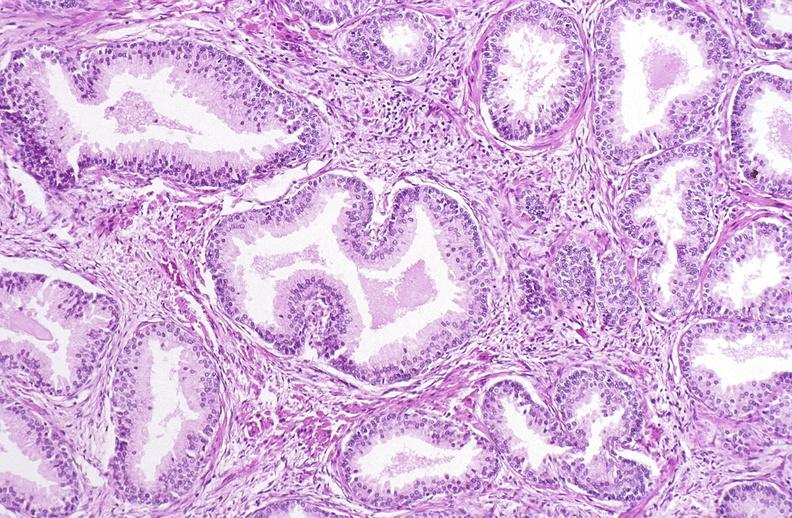what does this image show?
Answer the question using a single word or phrase. Prostate 